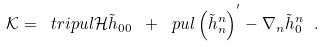Convert formula to latex. <formula><loc_0><loc_0><loc_500><loc_500>\mathcal { K } = \ t r i p u l { \mathcal { H } } { \tilde { h } } _ { 0 0 } \ + \ p u l \left ( { \tilde { h } } ^ { n } _ { n } \right ) ^ { ^ { \prime } } - \nabla _ { n } { \tilde { h } } ^ { n } _ { 0 } \ .</formula> 